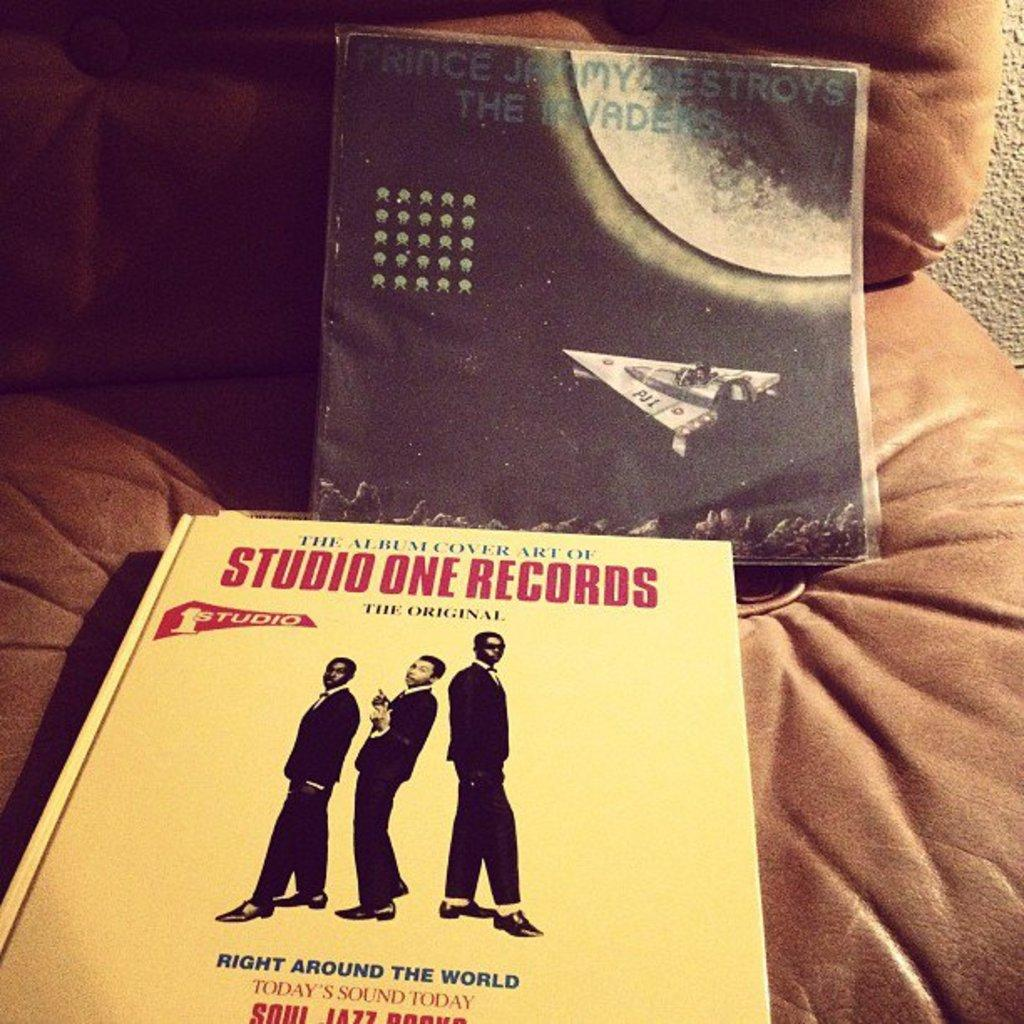<image>
Create a compact narrative representing the image presented. A Stone One Records original on a couch. 